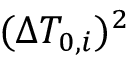Convert formula to latex. <formula><loc_0><loc_0><loc_500><loc_500>( \Delta T _ { 0 , i } ) ^ { 2 }</formula> 